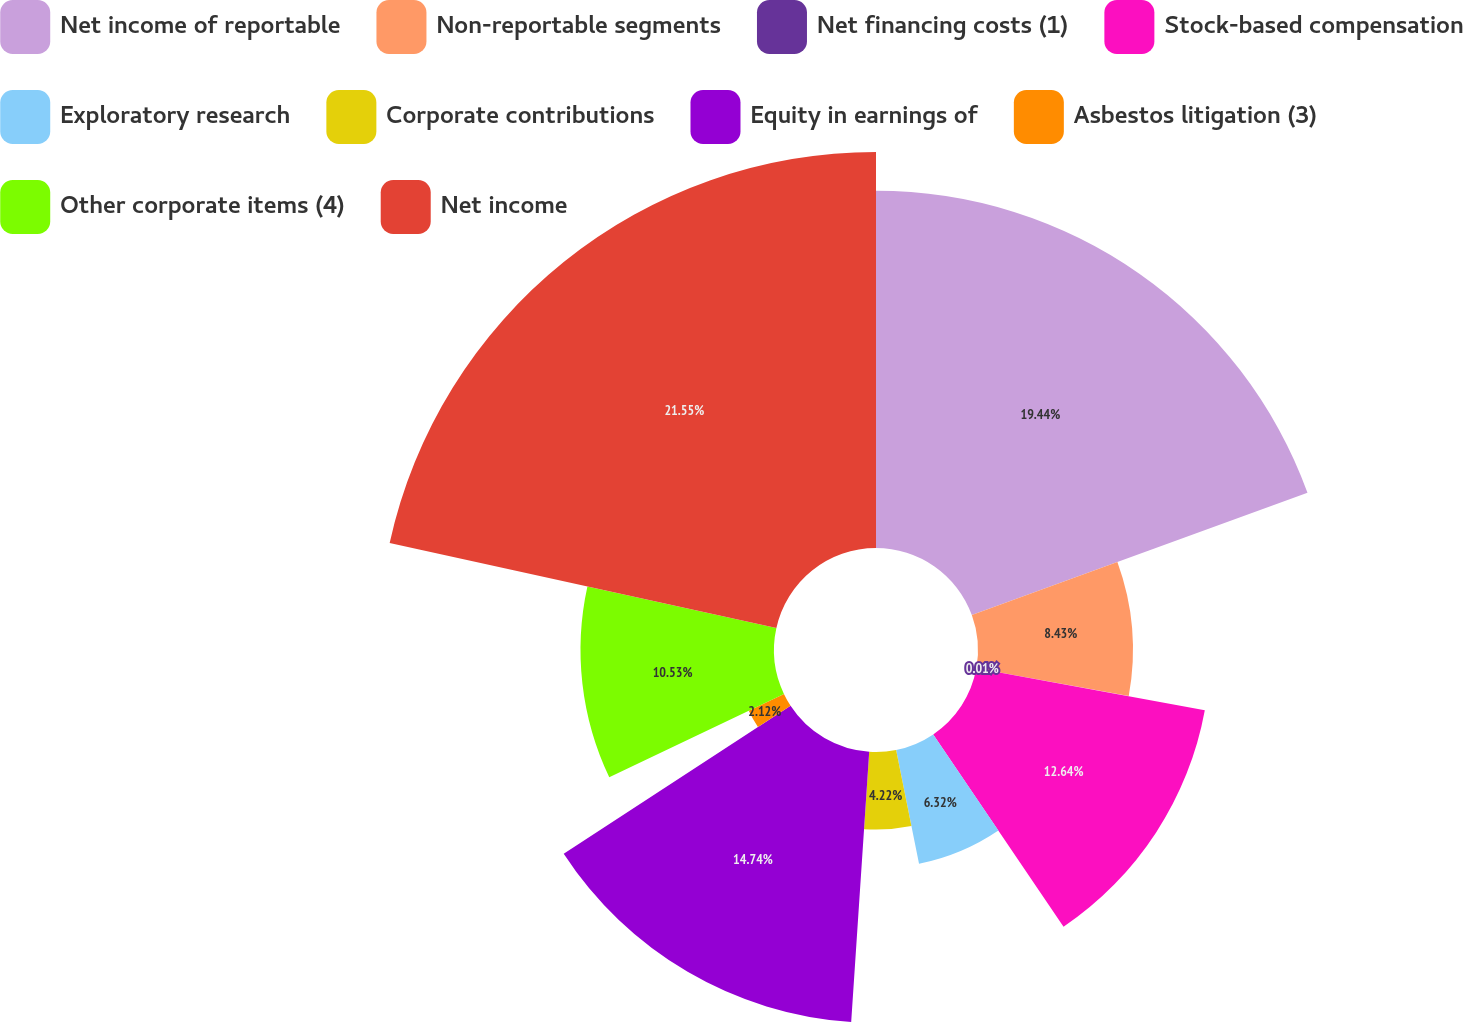<chart> <loc_0><loc_0><loc_500><loc_500><pie_chart><fcel>Net income of reportable<fcel>Non-reportable segments<fcel>Net financing costs (1)<fcel>Stock-based compensation<fcel>Exploratory research<fcel>Corporate contributions<fcel>Equity in earnings of<fcel>Asbestos litigation (3)<fcel>Other corporate items (4)<fcel>Net income<nl><fcel>19.44%<fcel>8.43%<fcel>0.01%<fcel>12.64%<fcel>6.32%<fcel>4.22%<fcel>14.74%<fcel>2.12%<fcel>10.53%<fcel>21.55%<nl></chart> 